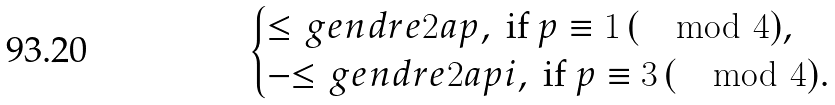<formula> <loc_0><loc_0><loc_500><loc_500>\begin{cases} { \leq g e n d r e { 2 a } { p } } , \text { if } p \equiv 1 \, ( \mod 4 ) , \\ - { \leq g e n d r e { 2 a } { p } } i , \text { if } p \equiv 3 \, ( \mod 4 ) . \end{cases}</formula> 